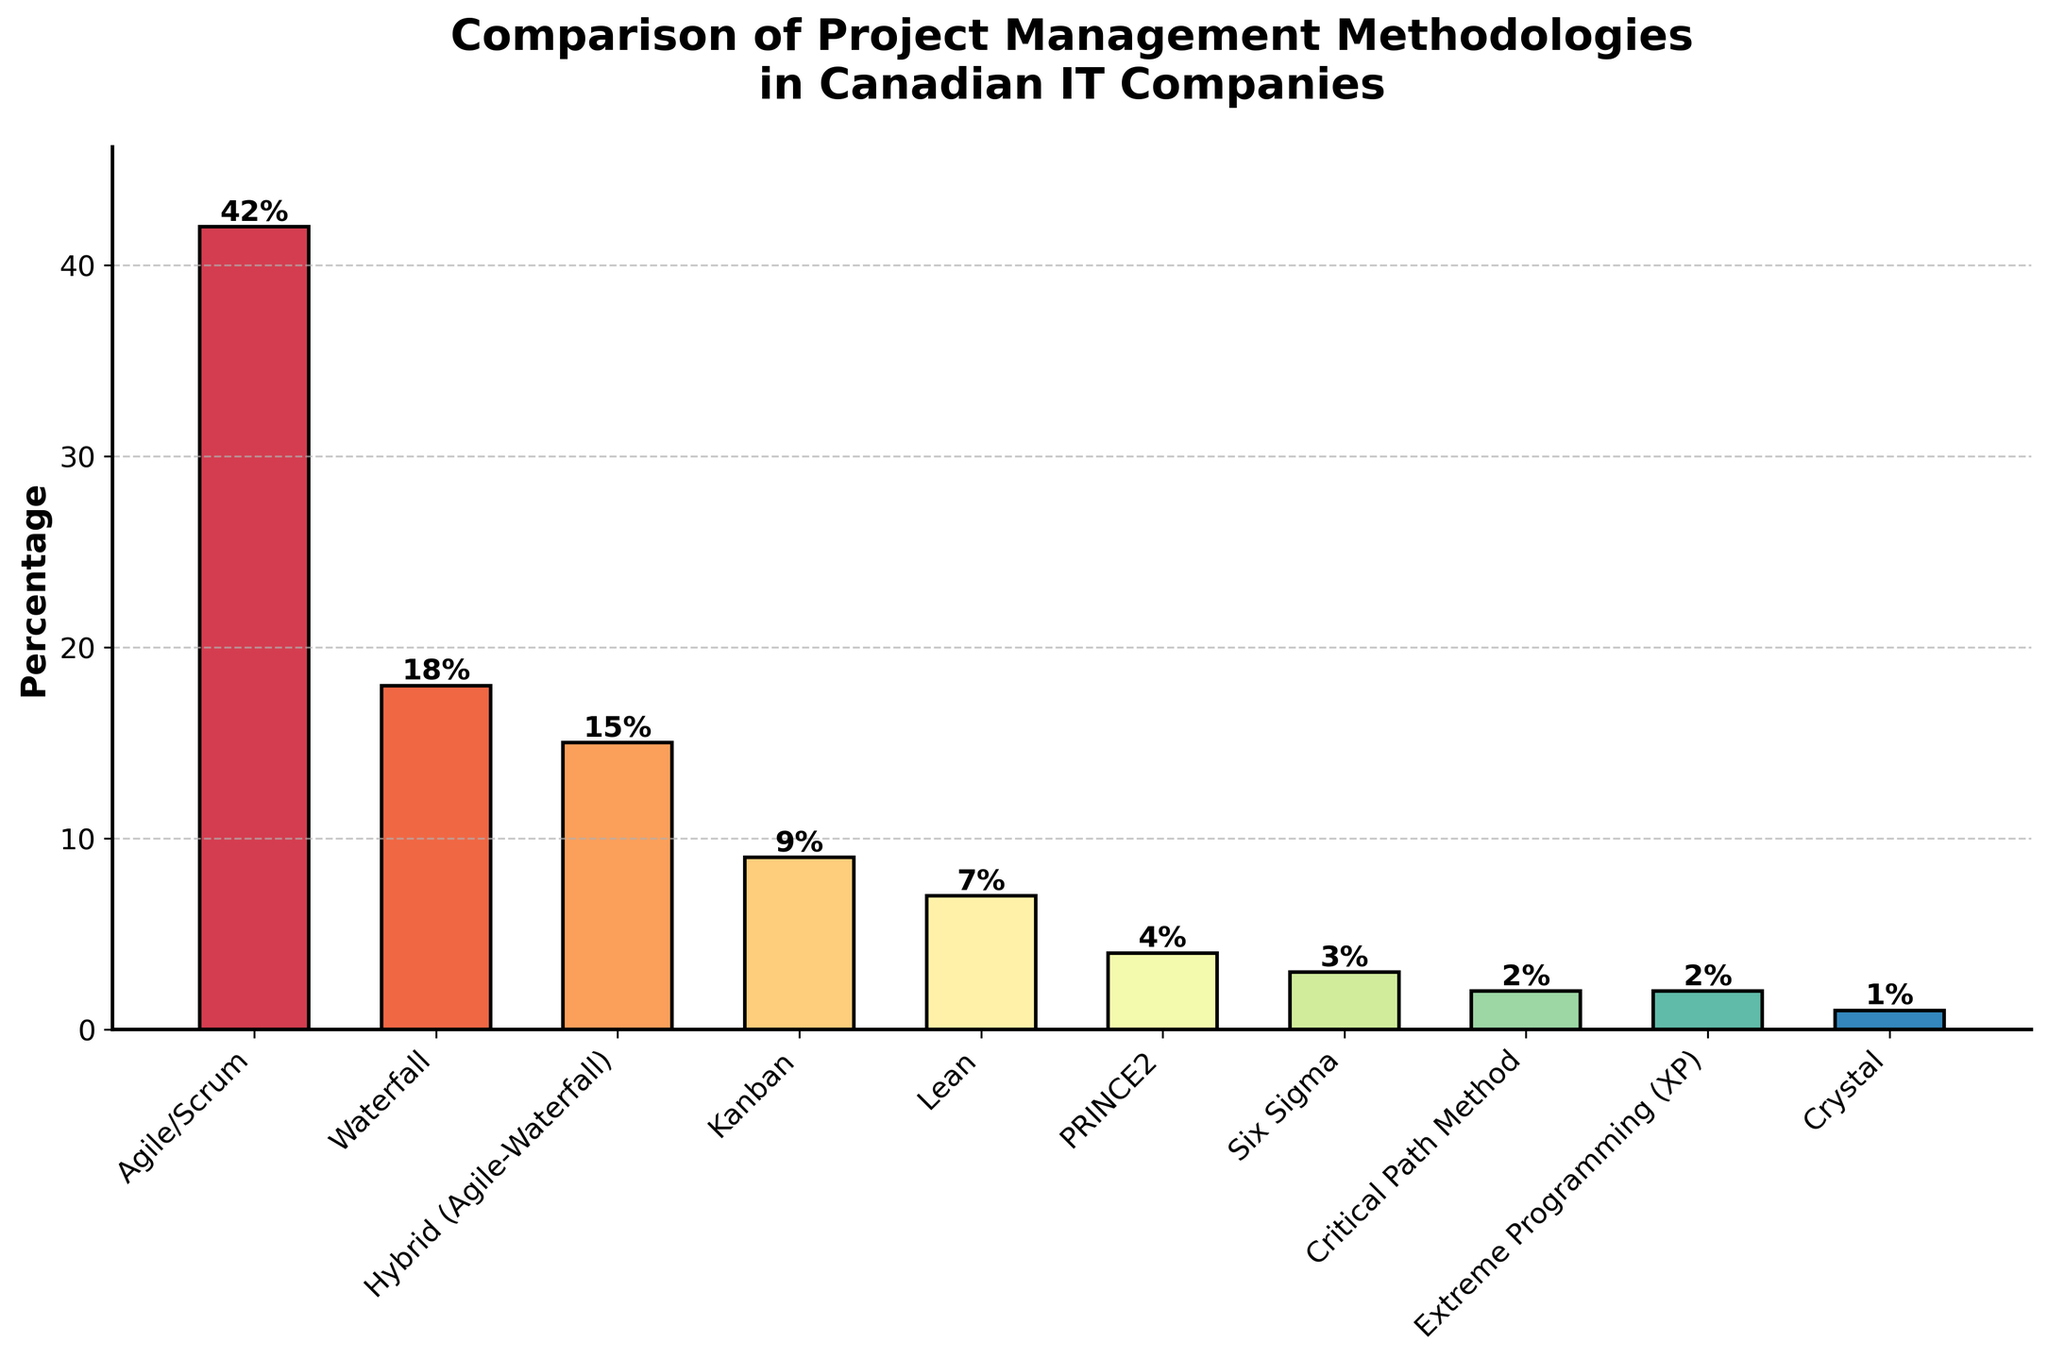What percentage of Canadian IT companies use Agile/Scrum methodology? The bar corresponding to Agile/Scrum shows a height labeled with the percentage value, which is 42.
Answer: 42% Which project management methodology is the least used in Canadian IT companies? The shortest bar corresponds to the methodology with the lowest percentage, which is Crystal with 1%.
Answer: Crystal What is the combined percentage of Canadian IT companies using PRINCE2 and Six Sigma methodologies? Add the percentages for PRINCE2 (4%) and Six Sigma (3%) to get the combined value (4 + 3 = 7).
Answer: 7% How many Canadian IT companies use Waterfall methodology compared to those using Kanban? Compare the bars for Waterfall (18%) and Kanban (9%). Waterfall has a higher percentage.
Answer: Waterfall uses more Is the percentage of companies using Lean methodology greater than those using Hybrid (Agile-Waterfall)? Compare the bars for Lean (7%) and Hybrid (15%). The bar for Hybrid is taller than Lean.
Answer: No, Lean is less Calculate the difference in percentage between Agile/Scrum and Waterfall methodologies. Subtract the percentage of Waterfall (18) from Agile/Scrum (42): 42 - 18 = 24.
Answer: 24% What is the average percentage of companies using either Kanban or Lean? Calculate the sum of percentages for Kanban (9) and Lean (7), then divide by the number of methodologies: (9 + 7)/2 = 8.
Answer: 8% Compare the height of the bar for Extreme Programming (XP) and Critical Path Method. Which one is higher? Both bars show the same height labeled as 2%. Both methodologies have the same percentage.
Answer: Same height What visual feature helps in distinguishing different methodologies easily in the bar chart? The bars are color-coded using different colors from a color spectrum, which helps distinguish between them.
Answer: Different colors What is the total percentage of companies using methodologies other than Agile/Scrum? Subtract the percentage of Agile/Scrum from 100: 100 - 42 = 58.
Answer: 58% 